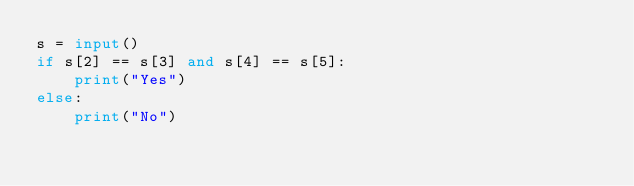Convert code to text. <code><loc_0><loc_0><loc_500><loc_500><_Python_>s = input()
if s[2] == s[3] and s[4] == s[5]:
    print("Yes")
else:
    print("No")</code> 